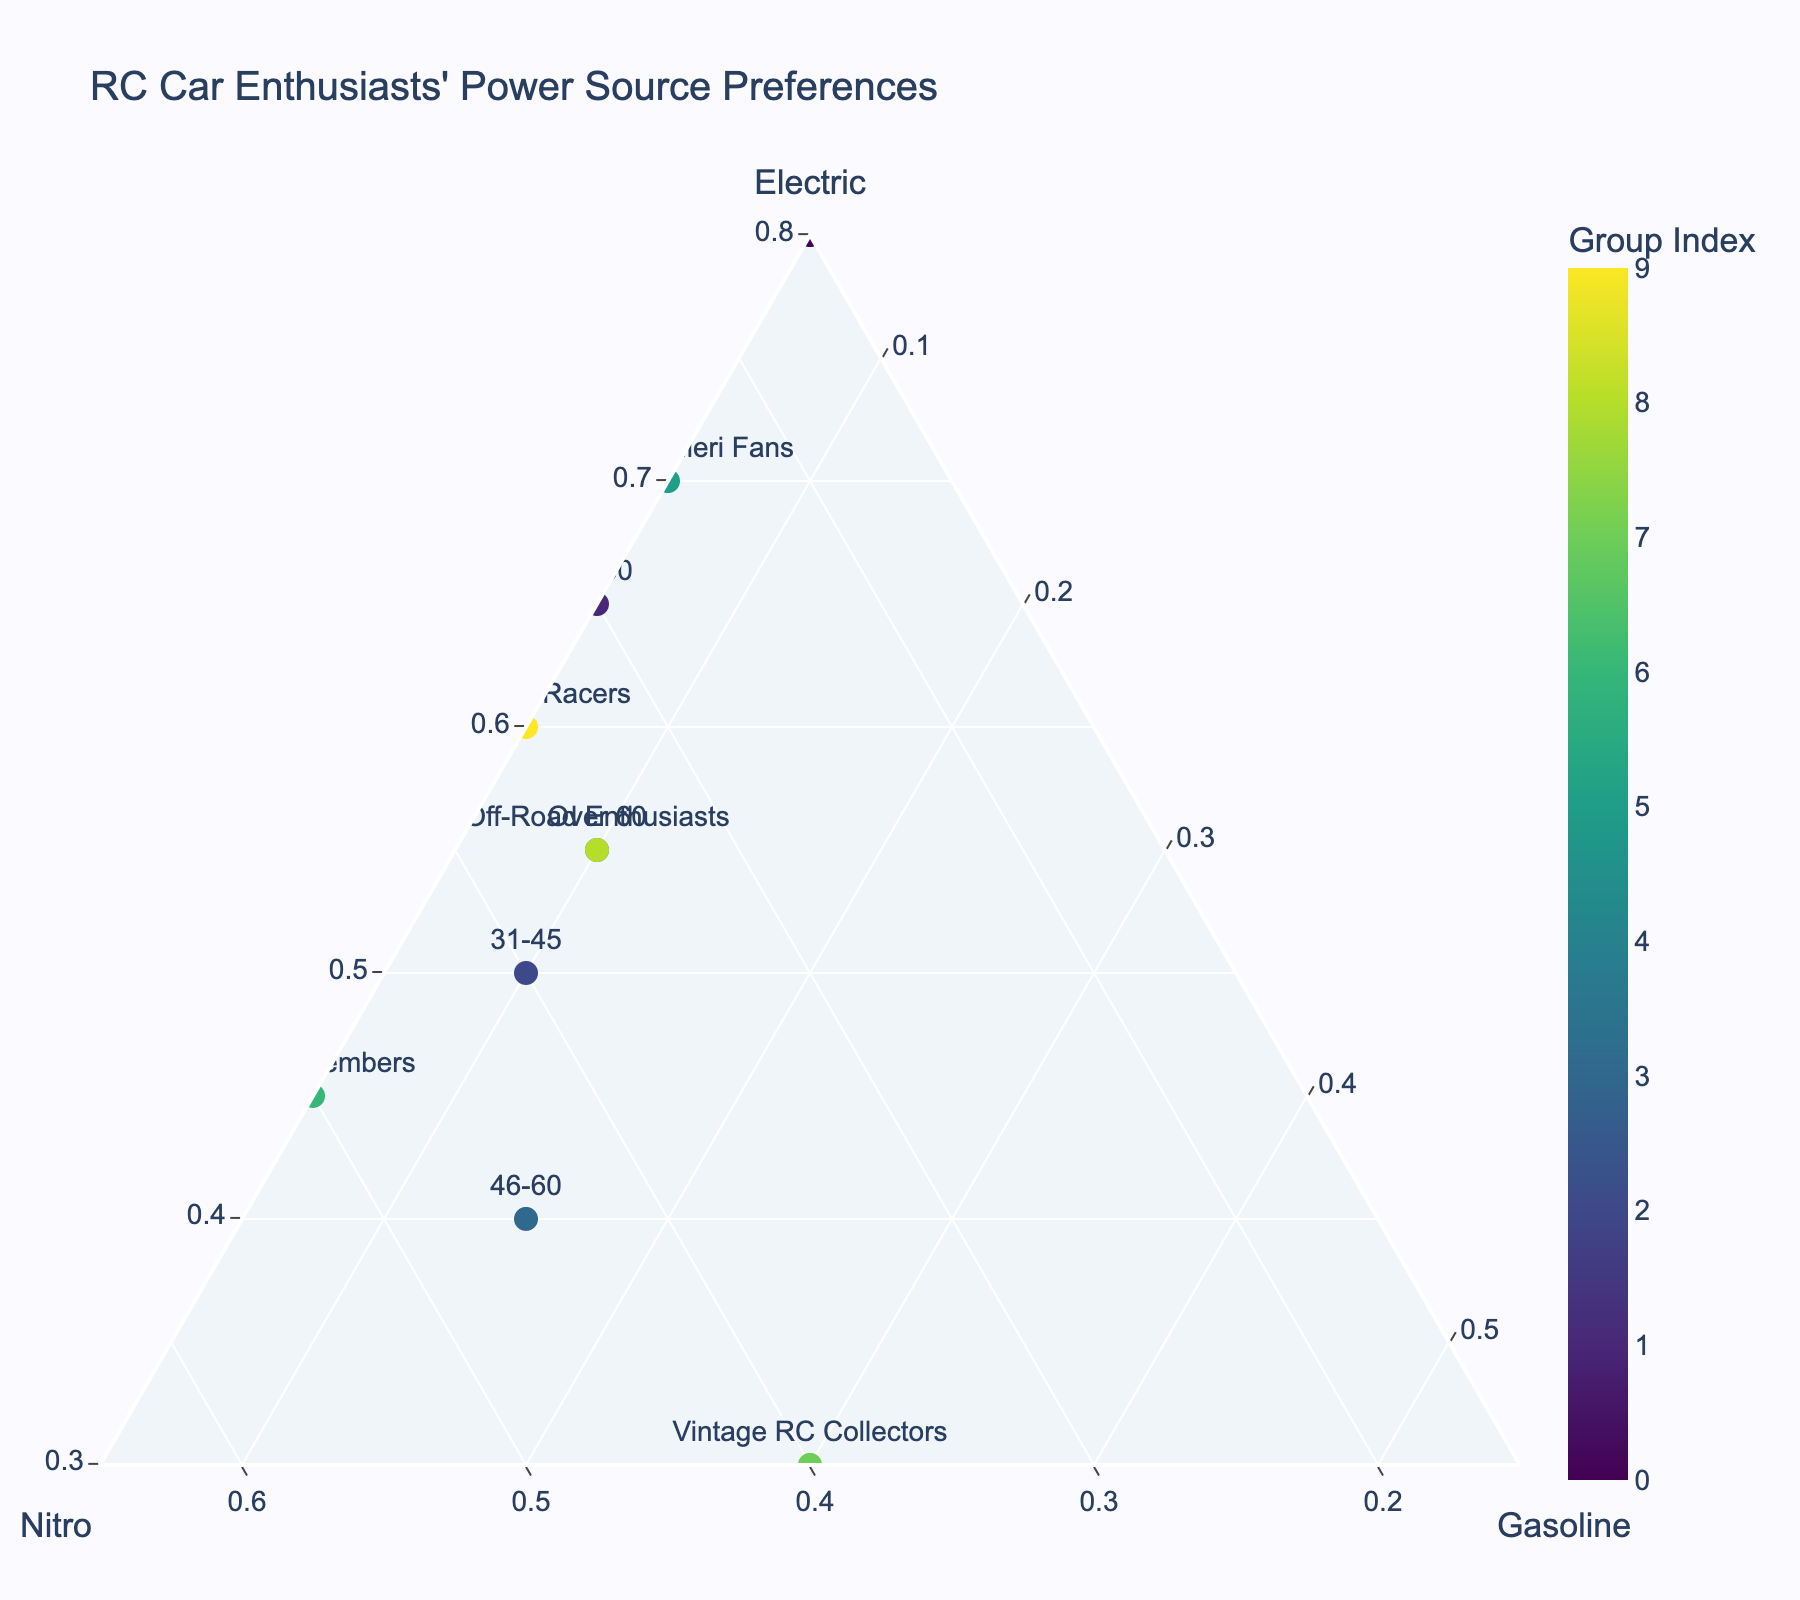What's the title of the figure? The title of the figure is located at the top and is usually in a larger font size.
Answer: RC Car Enthusiasts' Power Source Preferences How many groups are represented in the plot? By counting the number of unique labels/texts next to the markers, you can find the total number of groups.
Answer: 10 Which group prefers electric power the most? By looking for the marker that is closest to the apex labeled "Electric" and checking the corresponding group text.
Answer: Under 18 What is the average preference percentage for Nitro power among Vintage RC Collectors and ROAR Members? Identify the Nitro values for both Vintage RC Collectors (0.40) and ROAR Members (0.50). Average them: (0.40 + 0.50) / 2.
Answer: 0.45 Which age group has a preference balance closest to equal among the three power sources? The balance can be identified by looking for a point near the centroid of the ternary plot where the proportions of Electric, Nitro, and Gasoline are more balanced.
Answer: 46-60 How do Ryan Cavalieri Fans' preferences compare to Off-Road Enthusiasts' preferences for Nitro power? Identify the Nitro preference of Ryan Cavalieri Fans (0.25) and Off-Road Enthusiasts (0.35), then compare them.
Answer: Ryan Cavalieri Fans have a lower Nitro preference Which group has the highest preference for Gasoline? Look for the marker closest to the apex labeled "Gasoline" and check the group text.
Answer: Vintage RC Collectors What is the sum of Electric preferences for the 18-30 and Over 60 age groups? Identify Electric preferences for 18-30 (0.65) and Over 60 (0.55), then sum them: 0.65 + 0.55.
Answer: 1.20 Do any groups have an identical preference for a power source? If so, which groups and which power source? Examine the preferences for each group and check for identical values.
Answer: 18-30 and On-Road Racers have identical preferences for Gasoline (0.05) 